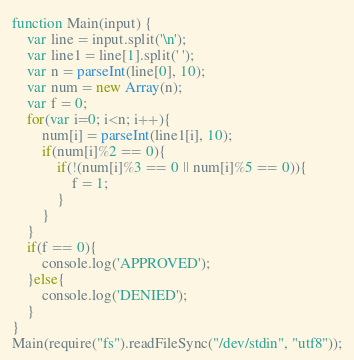<code> <loc_0><loc_0><loc_500><loc_500><_JavaScript_>function Main(input) {
	var line = input.split('\n');
	var line1 = line[1].split(' ');
	var n = parseInt(line[0], 10);
	var num = new Array(n);
	var f = 0;
	for(var i=0; i<n; i++){
		num[i] = parseInt(line1[i], 10);
		if(num[i]%2 == 0){
			if(!(num[i]%3 == 0 || num[i]%5 == 0)){
				f = 1;
			}
		}
	}
	if(f == 0){
		console.log('APPROVED');
	}else{
		console.log('DENIED');
	}
}
Main(require("fs").readFileSync("/dev/stdin", "utf8"));
</code> 